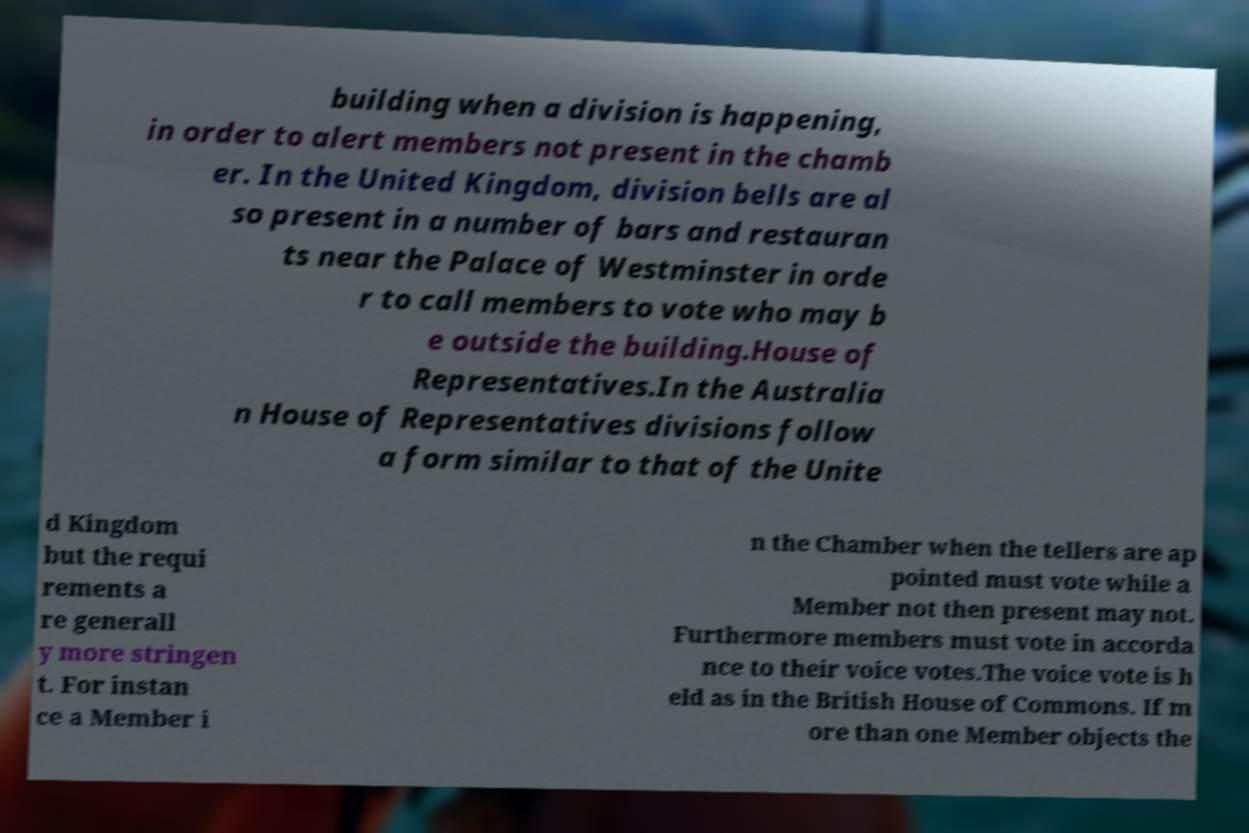Can you accurately transcribe the text from the provided image for me? building when a division is happening, in order to alert members not present in the chamb er. In the United Kingdom, division bells are al so present in a number of bars and restauran ts near the Palace of Westminster in orde r to call members to vote who may b e outside the building.House of Representatives.In the Australia n House of Representatives divisions follow a form similar to that of the Unite d Kingdom but the requi rements a re generall y more stringen t. For instan ce a Member i n the Chamber when the tellers are ap pointed must vote while a Member not then present may not. Furthermore members must vote in accorda nce to their voice votes.The voice vote is h eld as in the British House of Commons. If m ore than one Member objects the 